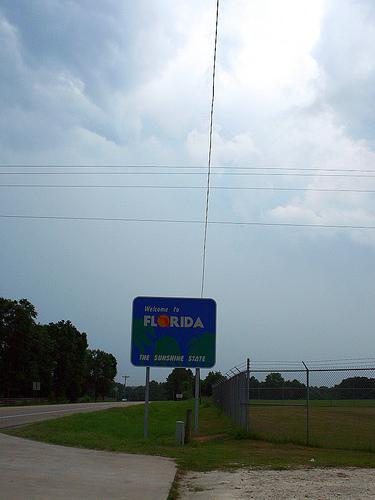Question: what's mostly under the sign?
Choices:
A. Flowers.
B. Dirt.
C. Grass.
D. Cement.
Answer with the letter. Answer: C Question: what's the sky look like?
Choices:
A. Cloudy.
B. Sunny.
C. Blue.
D. Dark.
Answer with the letter. Answer: A Question: what color is the sign mostly?
Choices:
A. Red.
B. Blue.
C. Black.
D. White.
Answer with the letter. Answer: B Question: where are the travelers?
Choices:
A. Maine.
B. Florida.
C. Texas.
D. Illinois.
Answer with the letter. Answer: B Question: what are the lines in the sky?
Choices:
A. Plane trails.
B. Migrating birds.
C. Sun spots.
D. Power lines.
Answer with the letter. Answer: D 